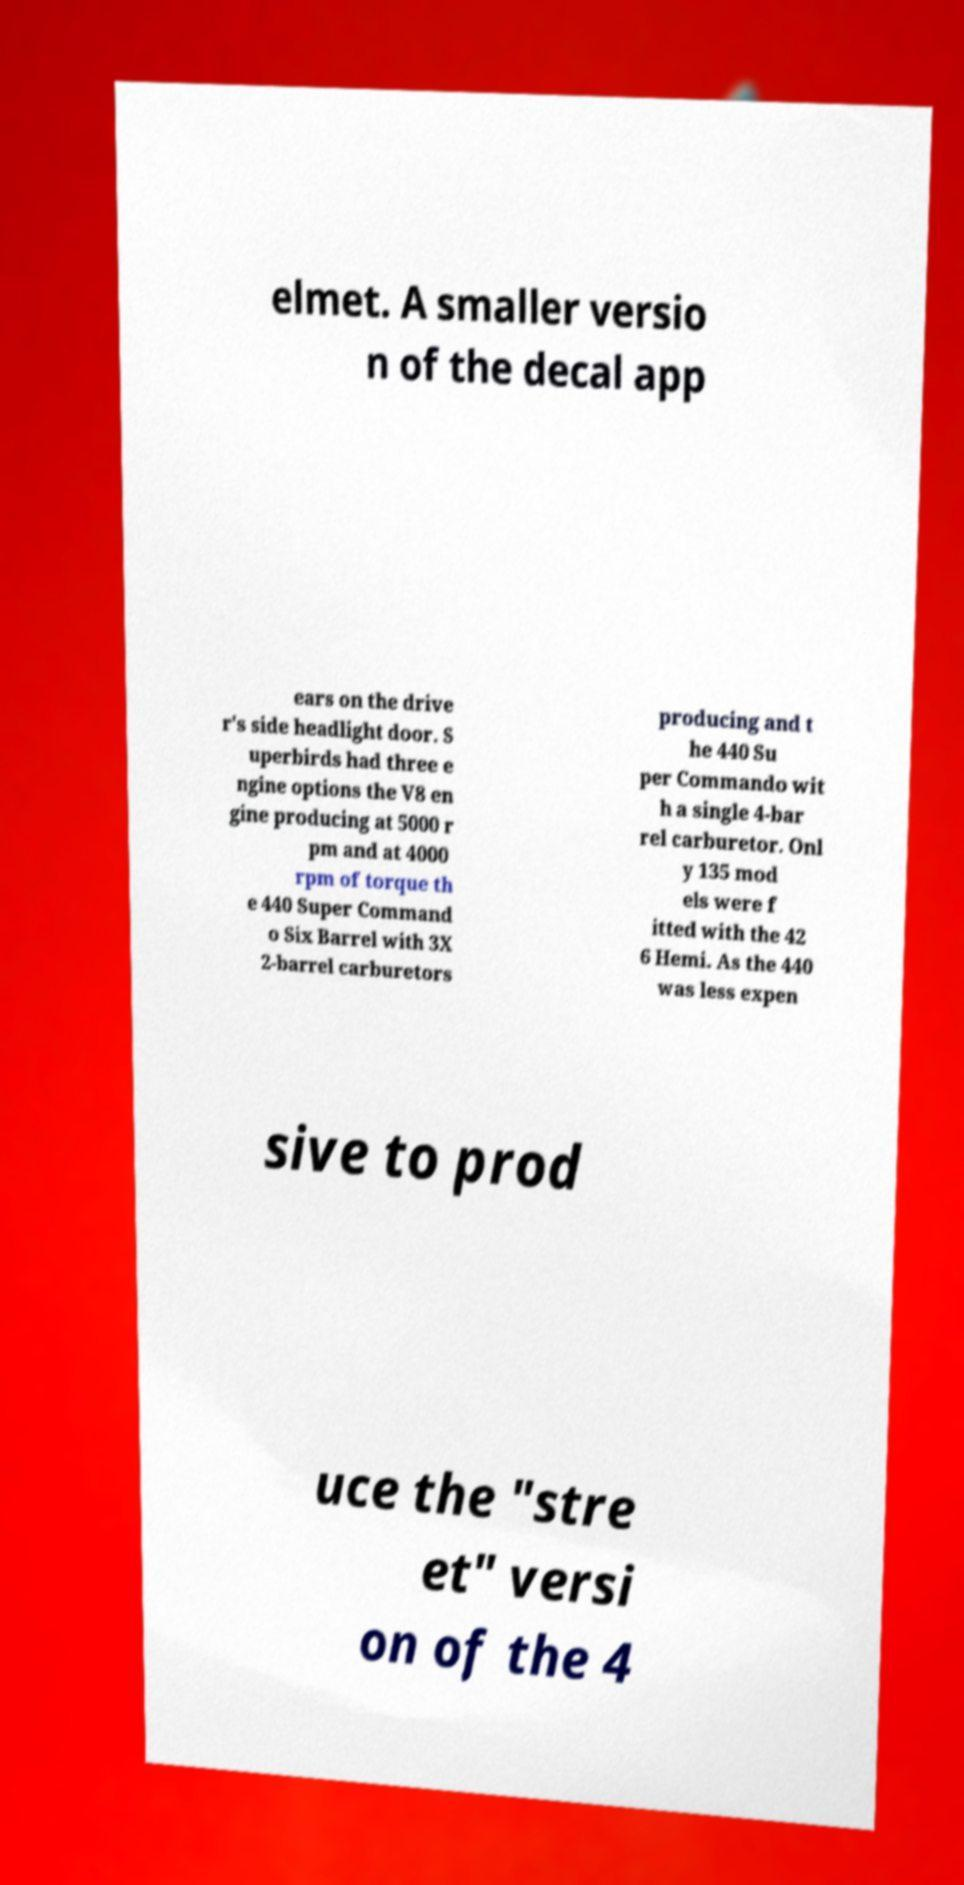Could you assist in decoding the text presented in this image and type it out clearly? elmet. A smaller versio n of the decal app ears on the drive r's side headlight door. S uperbirds had three e ngine options the V8 en gine producing at 5000 r pm and at 4000 rpm of torque th e 440 Super Command o Six Barrel with 3X 2-barrel carburetors producing and t he 440 Su per Commando wit h a single 4-bar rel carburetor. Onl y 135 mod els were f itted with the 42 6 Hemi. As the 440 was less expen sive to prod uce the "stre et" versi on of the 4 